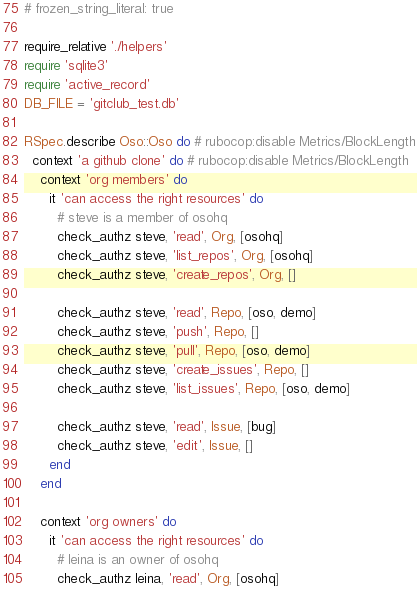Convert code to text. <code><loc_0><loc_0><loc_500><loc_500><_Ruby_># frozen_string_literal: true

require_relative './helpers'
require 'sqlite3'
require 'active_record'
DB_FILE = 'gitclub_test.db'

RSpec.describe Oso::Oso do # rubocop:disable Metrics/BlockLength
  context 'a github clone' do # rubocop:disable Metrics/BlockLength
    context 'org members' do
      it 'can access the right resources' do
        # steve is a member of osohq
        check_authz steve, 'read', Org, [osohq]
        check_authz steve, 'list_repos', Org, [osohq]
        check_authz steve, 'create_repos', Org, []

        check_authz steve, 'read', Repo, [oso, demo]
        check_authz steve, 'push', Repo, []
        check_authz steve, 'pull', Repo, [oso, demo]
        check_authz steve, 'create_issues', Repo, []
        check_authz steve, 'list_issues', Repo, [oso, demo]

        check_authz steve, 'read', Issue, [bug]
        check_authz steve, 'edit', Issue, []
      end
    end

    context 'org owners' do
      it 'can access the right resources' do
        # leina is an owner of osohq
        check_authz leina, 'read', Org, [osohq]</code> 